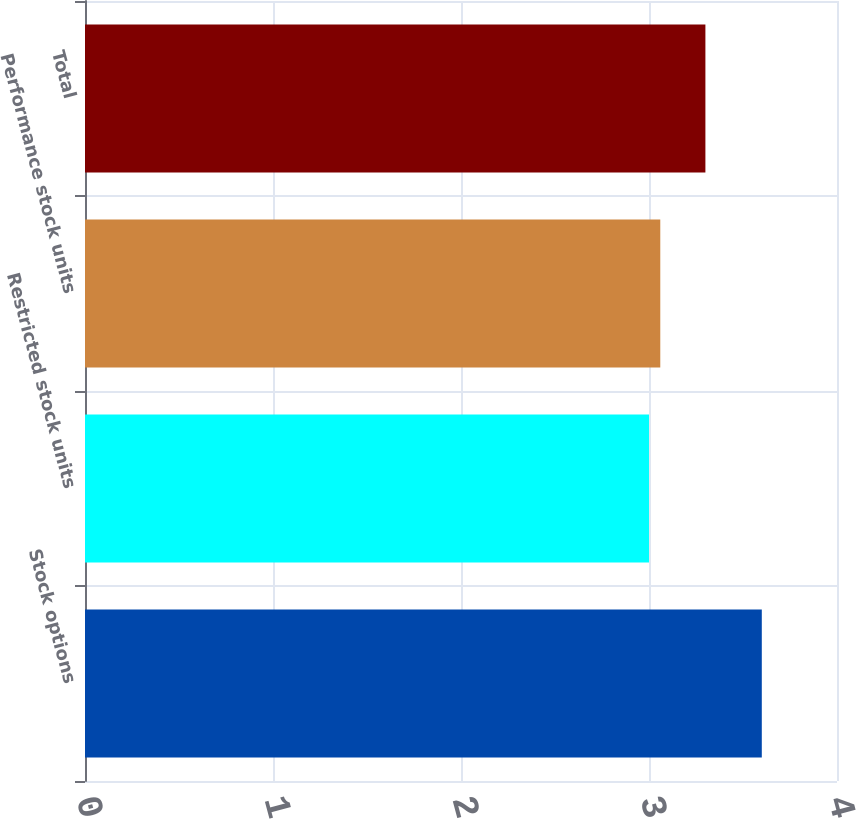Convert chart. <chart><loc_0><loc_0><loc_500><loc_500><bar_chart><fcel>Stock options<fcel>Restricted stock units<fcel>Performance stock units<fcel>Total<nl><fcel>3.6<fcel>3<fcel>3.06<fcel>3.3<nl></chart> 